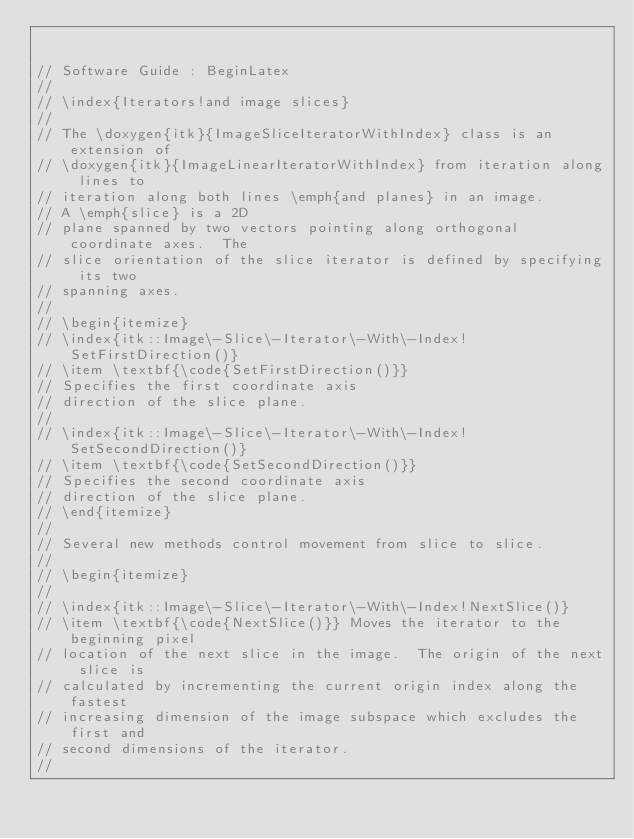<code> <loc_0><loc_0><loc_500><loc_500><_C++_>

// Software Guide : BeginLatex
//
// \index{Iterators!and image slices}
//
// The \doxygen{itk}{ImageSliceIteratorWithIndex} class is an extension of
// \doxygen{itk}{ImageLinearIteratorWithIndex} from iteration along lines to
// iteration along both lines \emph{and planes} in an image.
// A \emph{slice} is a 2D
// plane spanned by two vectors pointing along orthogonal coordinate axes.  The
// slice orientation of the slice iterator is defined by specifying its two
// spanning axes.
//
// \begin{itemize}
// \index{itk::Image\-Slice\-Iterator\-With\-Index!SetFirstDirection()}
// \item \textbf{\code{SetFirstDirection()}}
// Specifies the first coordinate axis
// direction of the slice plane.
//
// \index{itk::Image\-Slice\-Iterator\-With\-Index!SetSecondDirection()}
// \item \textbf{\code{SetSecondDirection()}}
// Specifies the second coordinate axis
// direction of the slice plane.
// \end{itemize}
//
// Several new methods control movement from slice to slice.
//
// \begin{itemize}
//
// \index{itk::Image\-Slice\-Iterator\-With\-Index!NextSlice()}
// \item \textbf{\code{NextSlice()}} Moves the iterator to the beginning pixel
// location of the next slice in the image.  The origin of the next slice is
// calculated by incrementing the current origin index along the fastest
// increasing dimension of the image subspace which excludes the first and
// second dimensions of the iterator.
//</code> 